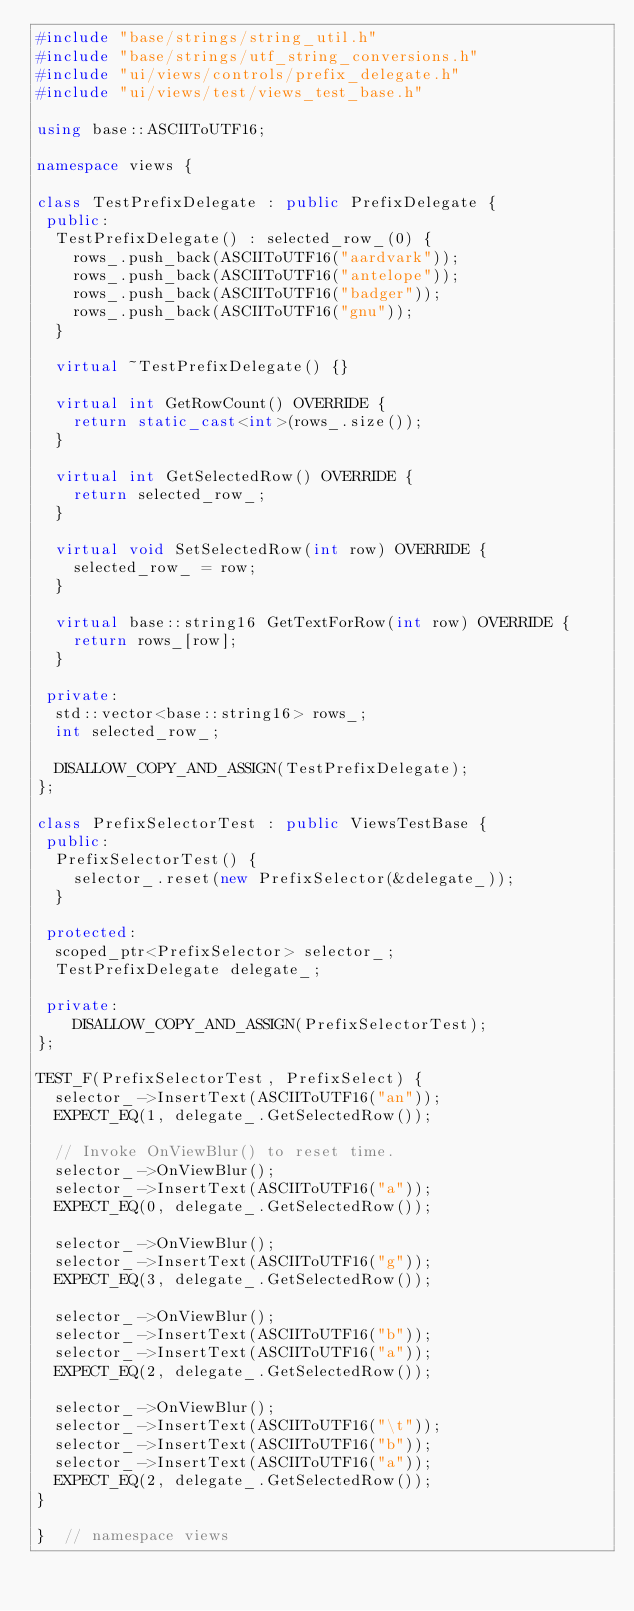Convert code to text. <code><loc_0><loc_0><loc_500><loc_500><_C++_>#include "base/strings/string_util.h"
#include "base/strings/utf_string_conversions.h"
#include "ui/views/controls/prefix_delegate.h"
#include "ui/views/test/views_test_base.h"

using base::ASCIIToUTF16;

namespace views {

class TestPrefixDelegate : public PrefixDelegate {
 public:
  TestPrefixDelegate() : selected_row_(0) {
    rows_.push_back(ASCIIToUTF16("aardvark"));
    rows_.push_back(ASCIIToUTF16("antelope"));
    rows_.push_back(ASCIIToUTF16("badger"));
    rows_.push_back(ASCIIToUTF16("gnu"));
  }

  virtual ~TestPrefixDelegate() {}

  virtual int GetRowCount() OVERRIDE {
    return static_cast<int>(rows_.size());
  }

  virtual int GetSelectedRow() OVERRIDE {
    return selected_row_;
  }

  virtual void SetSelectedRow(int row) OVERRIDE {
    selected_row_ = row;
  }

  virtual base::string16 GetTextForRow(int row) OVERRIDE {
    return rows_[row];
  }

 private:
  std::vector<base::string16> rows_;
  int selected_row_;

  DISALLOW_COPY_AND_ASSIGN(TestPrefixDelegate);
};

class PrefixSelectorTest : public ViewsTestBase {
 public:
  PrefixSelectorTest() {
    selector_.reset(new PrefixSelector(&delegate_));
  }

 protected:
  scoped_ptr<PrefixSelector> selector_;
  TestPrefixDelegate delegate_;

 private:
    DISALLOW_COPY_AND_ASSIGN(PrefixSelectorTest);
};

TEST_F(PrefixSelectorTest, PrefixSelect) {
  selector_->InsertText(ASCIIToUTF16("an"));
  EXPECT_EQ(1, delegate_.GetSelectedRow());

  // Invoke OnViewBlur() to reset time.
  selector_->OnViewBlur();
  selector_->InsertText(ASCIIToUTF16("a"));
  EXPECT_EQ(0, delegate_.GetSelectedRow());

  selector_->OnViewBlur();
  selector_->InsertText(ASCIIToUTF16("g"));
  EXPECT_EQ(3, delegate_.GetSelectedRow());

  selector_->OnViewBlur();
  selector_->InsertText(ASCIIToUTF16("b"));
  selector_->InsertText(ASCIIToUTF16("a"));
  EXPECT_EQ(2, delegate_.GetSelectedRow());

  selector_->OnViewBlur();
  selector_->InsertText(ASCIIToUTF16("\t"));
  selector_->InsertText(ASCIIToUTF16("b"));
  selector_->InsertText(ASCIIToUTF16("a"));
  EXPECT_EQ(2, delegate_.GetSelectedRow());
}

}  // namespace views
</code> 